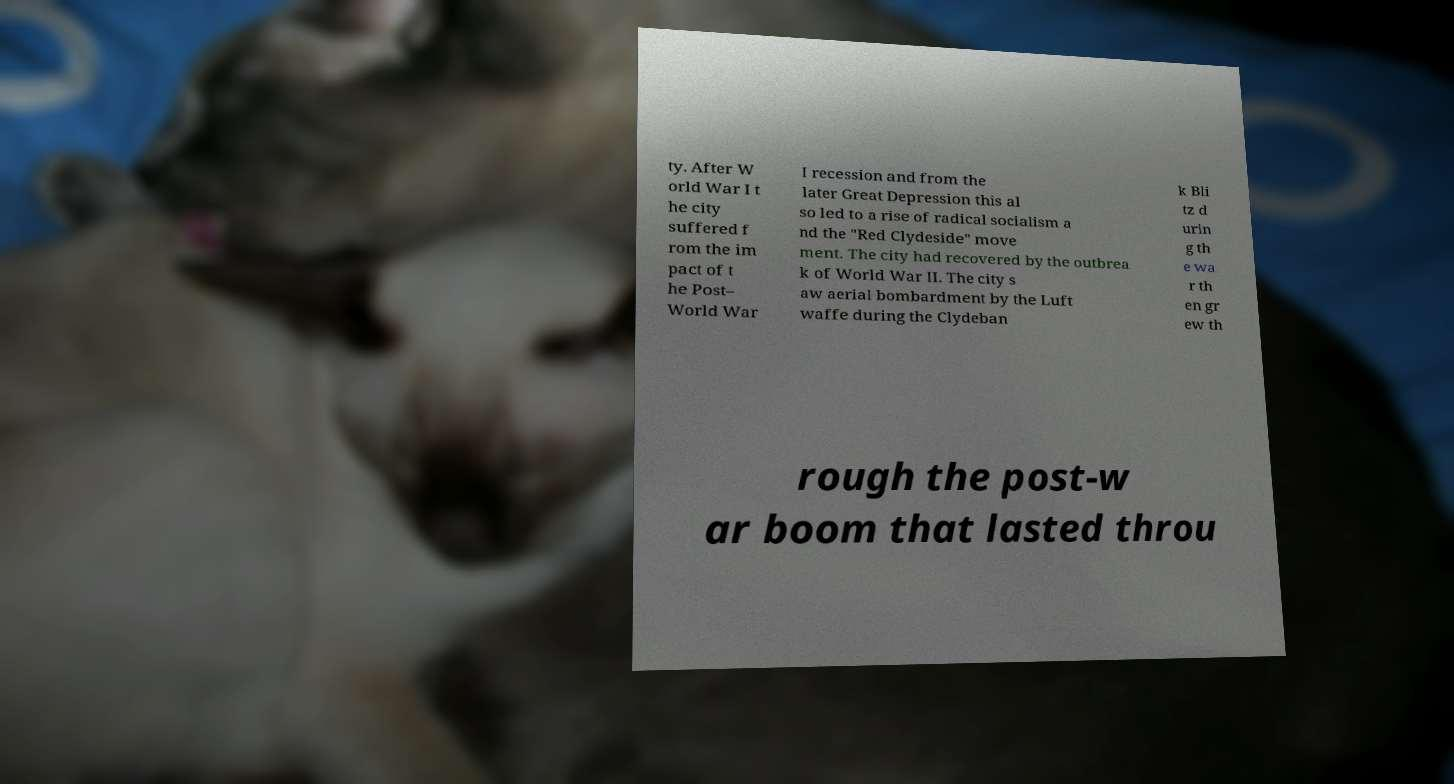Please read and relay the text visible in this image. What does it say? ty. After W orld War I t he city suffered f rom the im pact of t he Post– World War I recession and from the later Great Depression this al so led to a rise of radical socialism a nd the "Red Clydeside" move ment. The city had recovered by the outbrea k of World War II. The city s aw aerial bombardment by the Luft waffe during the Clydeban k Bli tz d urin g th e wa r th en gr ew th rough the post-w ar boom that lasted throu 